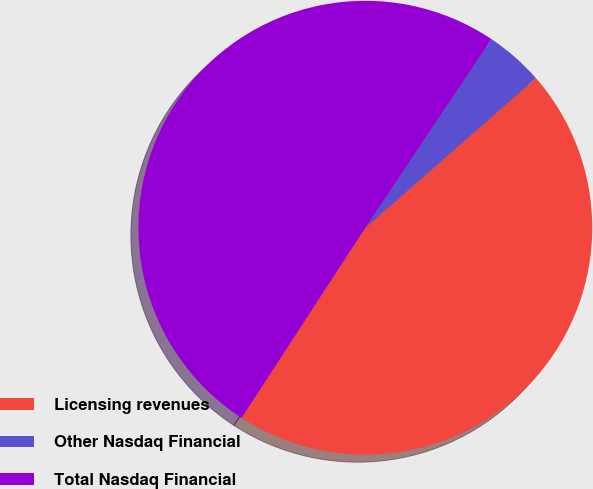Convert chart. <chart><loc_0><loc_0><loc_500><loc_500><pie_chart><fcel>Licensing revenues<fcel>Other Nasdaq Financial<fcel>Total Nasdaq Financial<nl><fcel>45.64%<fcel>4.16%<fcel>50.2%<nl></chart> 